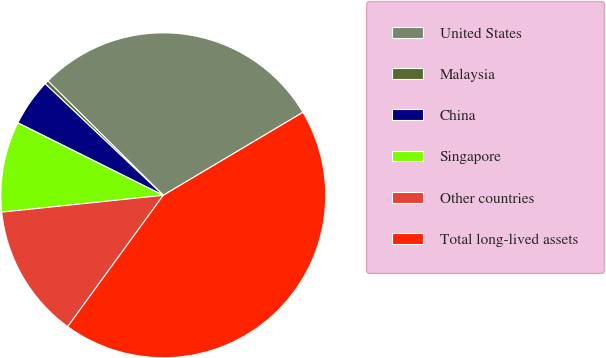Convert chart to OTSL. <chart><loc_0><loc_0><loc_500><loc_500><pie_chart><fcel>United States<fcel>Malaysia<fcel>China<fcel>Singapore<fcel>Other countries<fcel>Total long-lived assets<nl><fcel>29.04%<fcel>0.38%<fcel>4.69%<fcel>9.01%<fcel>13.33%<fcel>43.55%<nl></chart> 